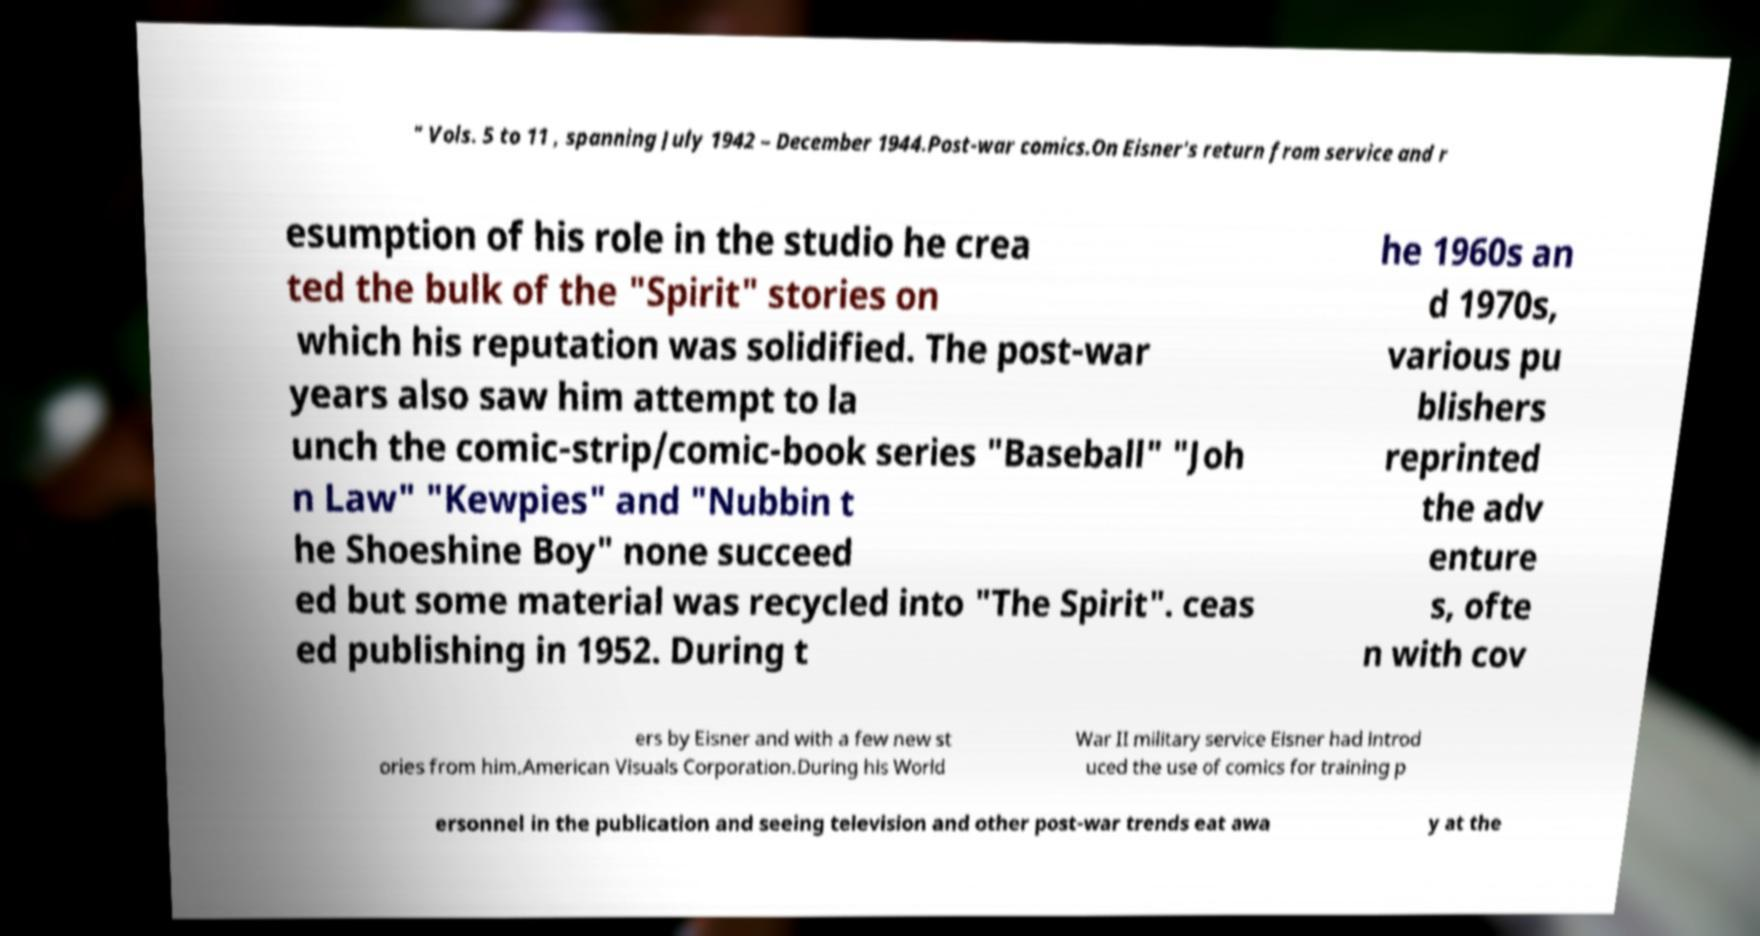There's text embedded in this image that I need extracted. Can you transcribe it verbatim? " Vols. 5 to 11 , spanning July 1942 – December 1944.Post-war comics.On Eisner's return from service and r esumption of his role in the studio he crea ted the bulk of the "Spirit" stories on which his reputation was solidified. The post-war years also saw him attempt to la unch the comic-strip/comic-book series "Baseball" "Joh n Law" "Kewpies" and "Nubbin t he Shoeshine Boy" none succeed ed but some material was recycled into "The Spirit". ceas ed publishing in 1952. During t he 1960s an d 1970s, various pu blishers reprinted the adv enture s, ofte n with cov ers by Eisner and with a few new st ories from him.American Visuals Corporation.During his World War II military service Eisner had introd uced the use of comics for training p ersonnel in the publication and seeing television and other post-war trends eat awa y at the 